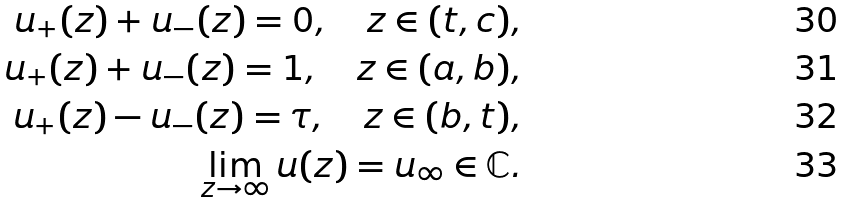<formula> <loc_0><loc_0><loc_500><loc_500>u _ { + } ( z ) + u _ { - } ( z ) = 0 , \quad z \in ( t , c ) , \\ u _ { + } ( z ) + u _ { - } ( z ) = 1 , \quad z \in ( a , b ) , \\ u _ { + } ( z ) - u _ { - } ( z ) = \tau , \quad z \in ( b , t ) , \\ \lim _ { z \to \infty } u ( z ) = u _ { \infty } \in \mathbb { C } .</formula> 